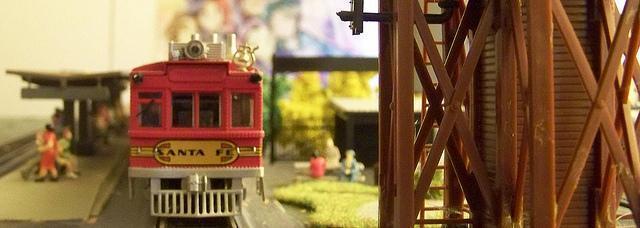How many baby giraffes are in the field?
Give a very brief answer. 0. 